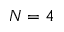<formula> <loc_0><loc_0><loc_500><loc_500>N = 4</formula> 